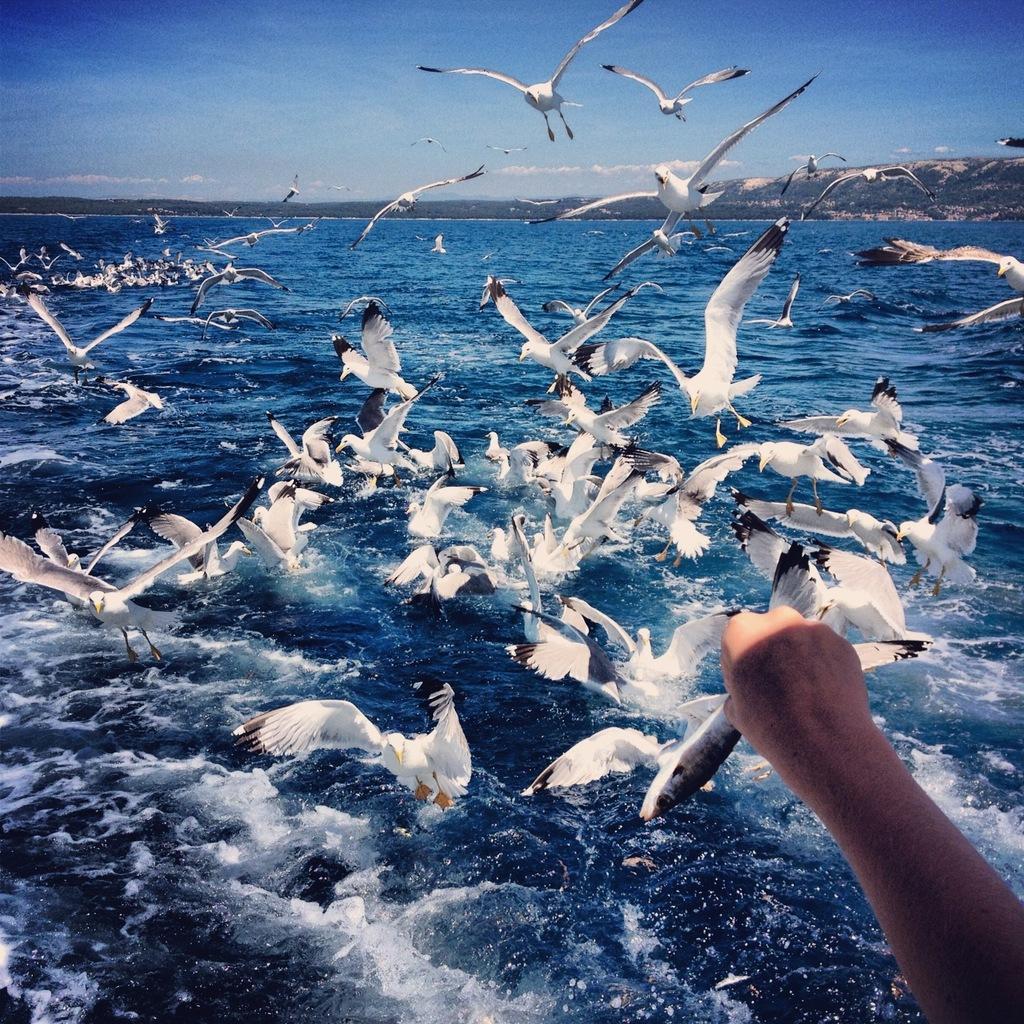How would you summarize this image in a sentence or two? In this image, we can see some water and birds. Among them, we can see some birds in the water. There are a few hills. We can also see the sky with clouds. We can also see the hand of a person. 